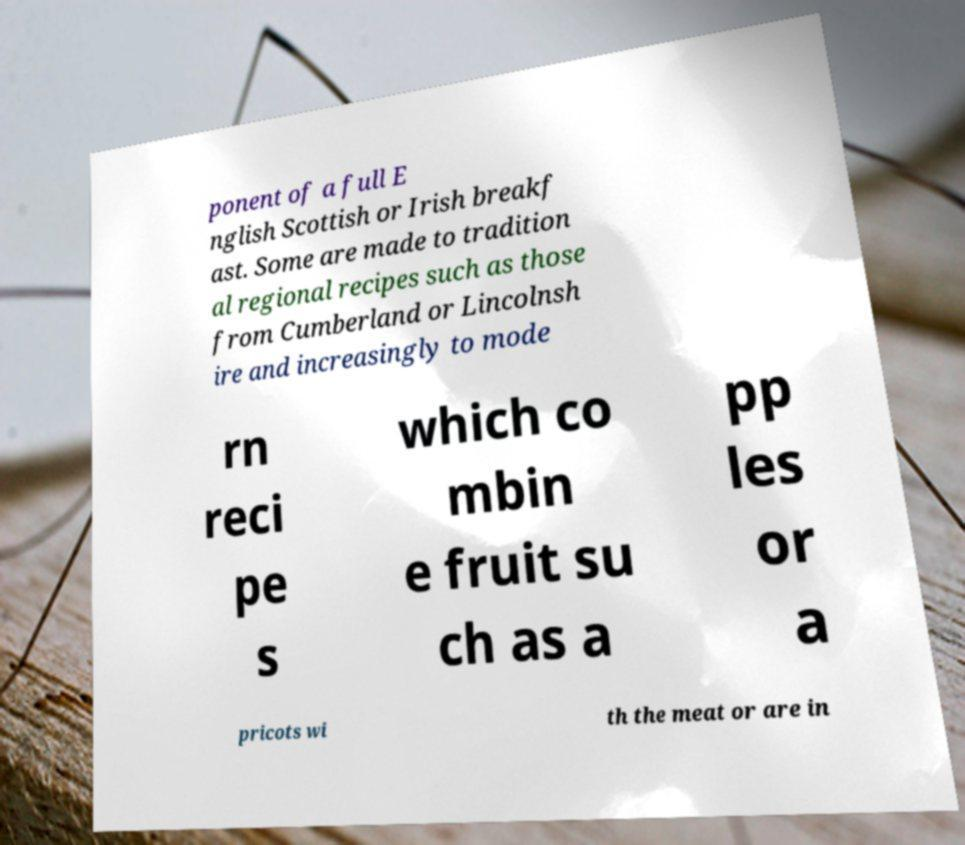Can you read and provide the text displayed in the image?This photo seems to have some interesting text. Can you extract and type it out for me? ponent of a full E nglish Scottish or Irish breakf ast. Some are made to tradition al regional recipes such as those from Cumberland or Lincolnsh ire and increasingly to mode rn reci pe s which co mbin e fruit su ch as a pp les or a pricots wi th the meat or are in 